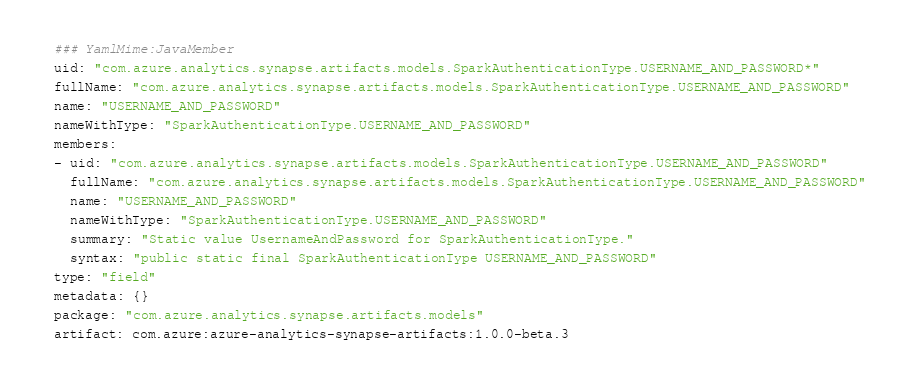<code> <loc_0><loc_0><loc_500><loc_500><_YAML_>### YamlMime:JavaMember
uid: "com.azure.analytics.synapse.artifacts.models.SparkAuthenticationType.USERNAME_AND_PASSWORD*"
fullName: "com.azure.analytics.synapse.artifacts.models.SparkAuthenticationType.USERNAME_AND_PASSWORD"
name: "USERNAME_AND_PASSWORD"
nameWithType: "SparkAuthenticationType.USERNAME_AND_PASSWORD"
members:
- uid: "com.azure.analytics.synapse.artifacts.models.SparkAuthenticationType.USERNAME_AND_PASSWORD"
  fullName: "com.azure.analytics.synapse.artifacts.models.SparkAuthenticationType.USERNAME_AND_PASSWORD"
  name: "USERNAME_AND_PASSWORD"
  nameWithType: "SparkAuthenticationType.USERNAME_AND_PASSWORD"
  summary: "Static value UsernameAndPassword for SparkAuthenticationType."
  syntax: "public static final SparkAuthenticationType USERNAME_AND_PASSWORD"
type: "field"
metadata: {}
package: "com.azure.analytics.synapse.artifacts.models"
artifact: com.azure:azure-analytics-synapse-artifacts:1.0.0-beta.3
</code> 